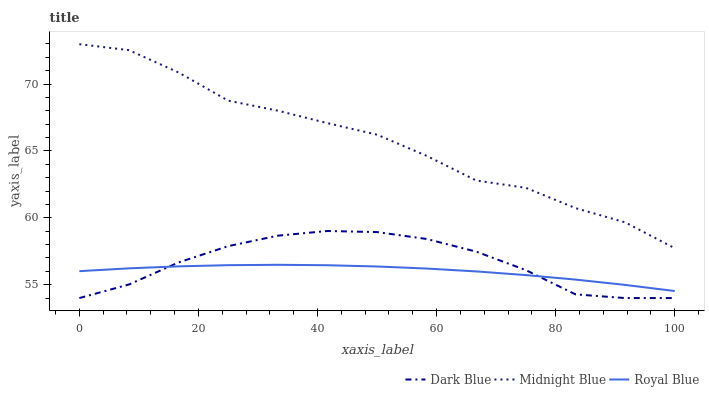Does Midnight Blue have the minimum area under the curve?
Answer yes or no. No. Does Royal Blue have the maximum area under the curve?
Answer yes or no. No. Is Midnight Blue the smoothest?
Answer yes or no. No. Is Royal Blue the roughest?
Answer yes or no. No. Does Royal Blue have the lowest value?
Answer yes or no. No. Does Royal Blue have the highest value?
Answer yes or no. No. Is Royal Blue less than Midnight Blue?
Answer yes or no. Yes. Is Midnight Blue greater than Royal Blue?
Answer yes or no. Yes. Does Royal Blue intersect Midnight Blue?
Answer yes or no. No. 